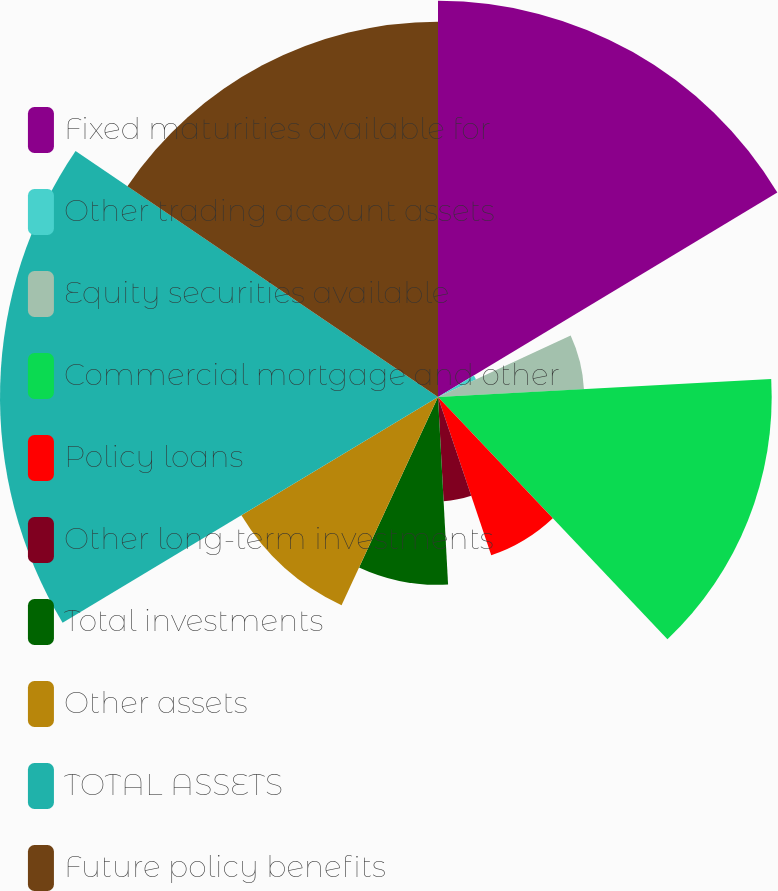Convert chart. <chart><loc_0><loc_0><loc_500><loc_500><pie_chart><fcel>Fixed maturities available for<fcel>Other trading account assets<fcel>Equity securities available<fcel>Commercial mortgage and other<fcel>Policy loans<fcel>Other long-term investments<fcel>Total investments<fcel>Other assets<fcel>TOTAL ASSETS<fcel>Future policy benefits<nl><fcel>16.37%<fcel>1.73%<fcel>6.04%<fcel>13.79%<fcel>6.9%<fcel>4.31%<fcel>7.76%<fcel>9.48%<fcel>18.1%<fcel>15.51%<nl></chart> 